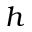<formula> <loc_0><loc_0><loc_500><loc_500>h</formula> 